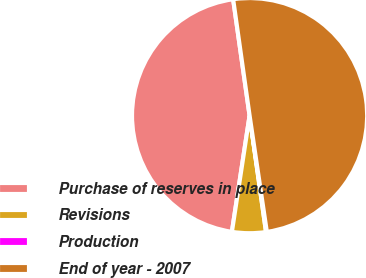Convert chart to OTSL. <chart><loc_0><loc_0><loc_500><loc_500><pie_chart><fcel>Purchase of reserves in place<fcel>Revisions<fcel>Production<fcel>End of year - 2007<nl><fcel>45.36%<fcel>4.64%<fcel>0.11%<fcel>49.89%<nl></chart> 